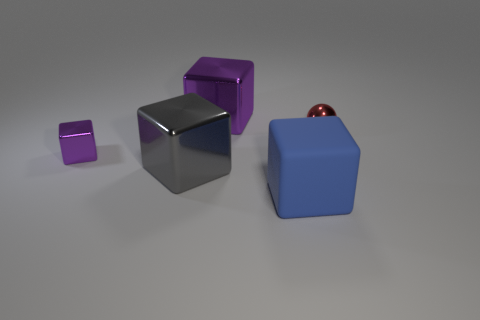What is the lighting like in the scene? The lighting in the image is soft and diffused, with gentle shadows cast by the blocks, indicating an evenly distributed light source, likely above and in front of the objects. The matte surfaces and reflections suggest an indoor setting with studio lighting. 